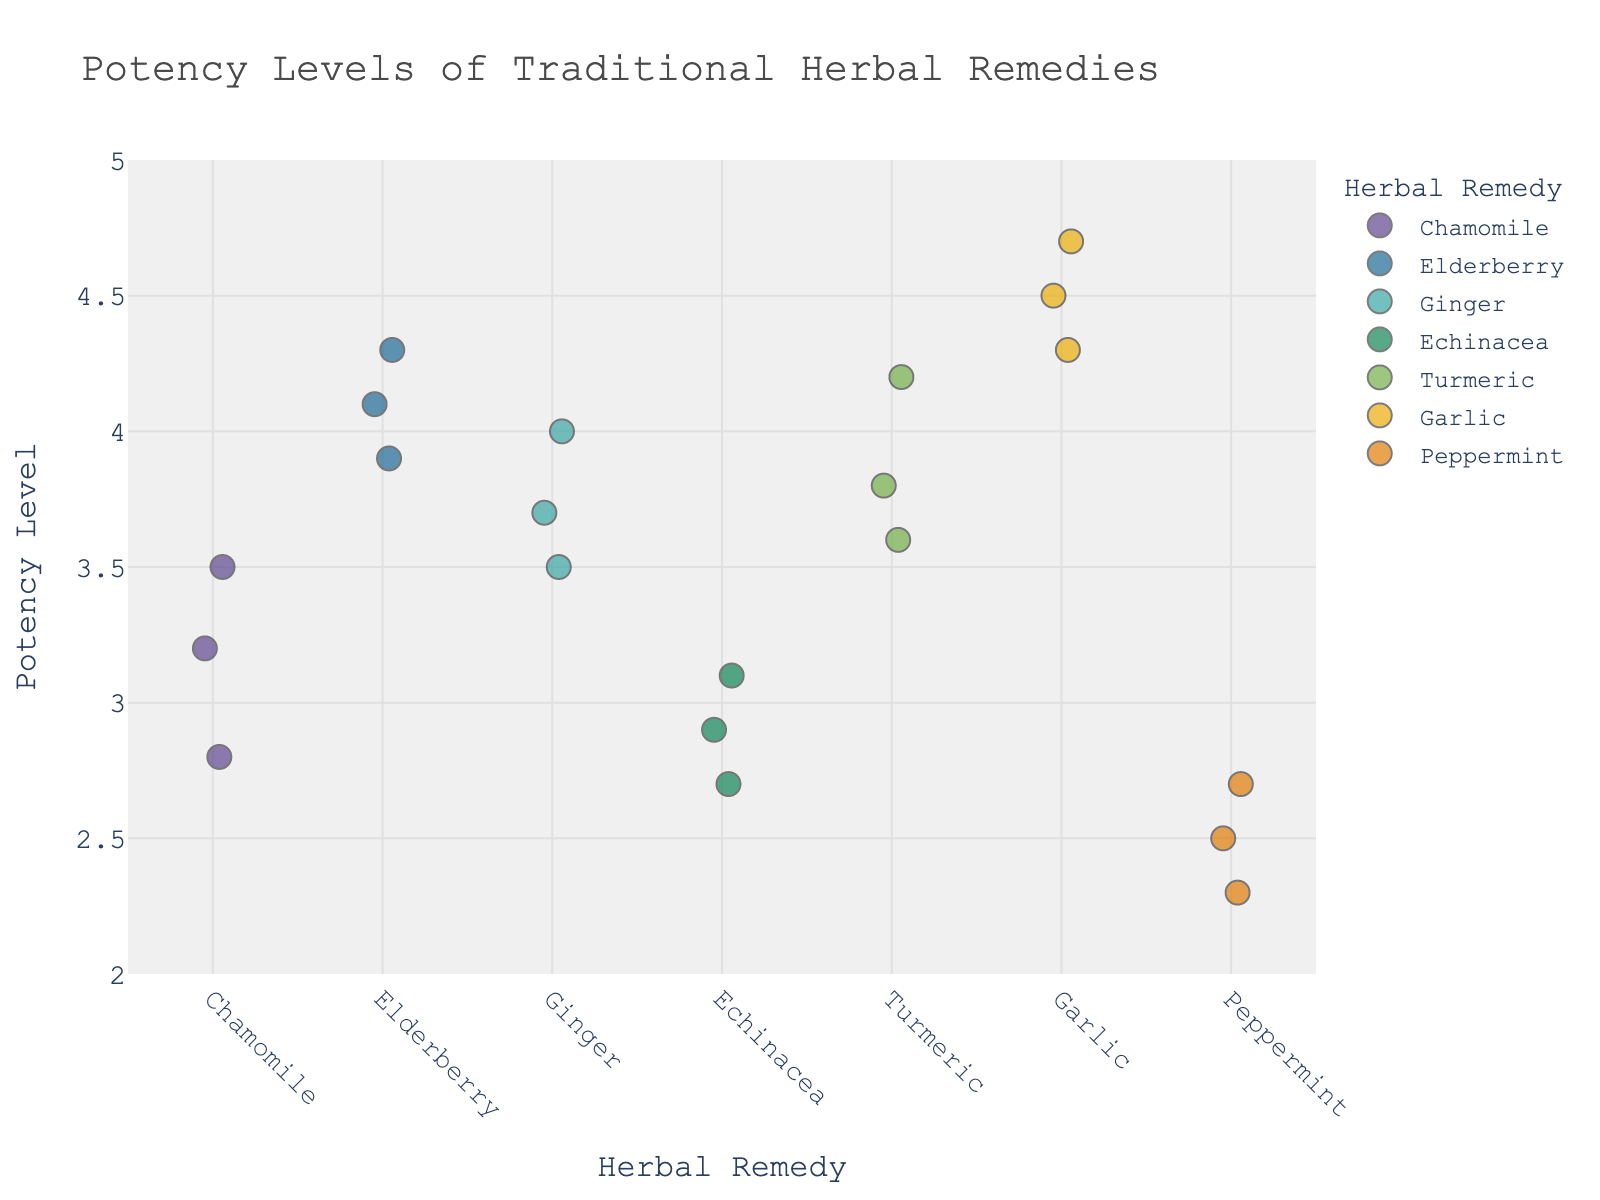What is the title of the plot? The title of a plot is typically located at the top of the graph, often in a larger and bold font size for visibility. Here, the title is clearly stated.
Answer: Potency Levels of Traditional Herbal Remedies Which herbal remedy has the highest potency level? By examining the y-axis values and identifying the highest data point, we see that Garlic has the highest recorded potency level.
Answer: Garlic How many data points are there for Chamomile? Count the number of individual markers for Chamomile on the x-axis to determine the number of data points. There are three markers.
Answer: 3 What is the average potency level for Echinacea? To find the average potency, sum up all potency levels for Echinacea and divide by the number of data points: (2.9 + 3.1 + 2.7) / 3 = 2.9
Answer: 2.9 Which herbal remedy has the most consistent potency levels? By looking at the spread of the data points for each herb, we see that Chamomile has the most consistent potency levels as its points are closer together.
Answer: Chamomile Which herb has a lower average potency level: Peppermint or Ginger? Calculate the average potency level for both Peppermint and Ginger. For Peppermint: (2.5 + 2.3 + 2.7) / 3 = 2.5. For Ginger: (3.7 + 3.5 + 4.0) / 3 = 3.73. Peppermint has the lower average potency level.
Answer: Peppermint What is the range of potency levels for Elderberry? The range is found by subtracting the lowest potency level from the highest: 4.3 - 3.9 = 0.4
Answer: 0.4 Which herb has the most data points with a potency level greater than 4.0? By visually inspecting the plot, we can see that Garlic has three data points above the 4.0 mark, which is the most among the herbs.
Answer: Garlic 